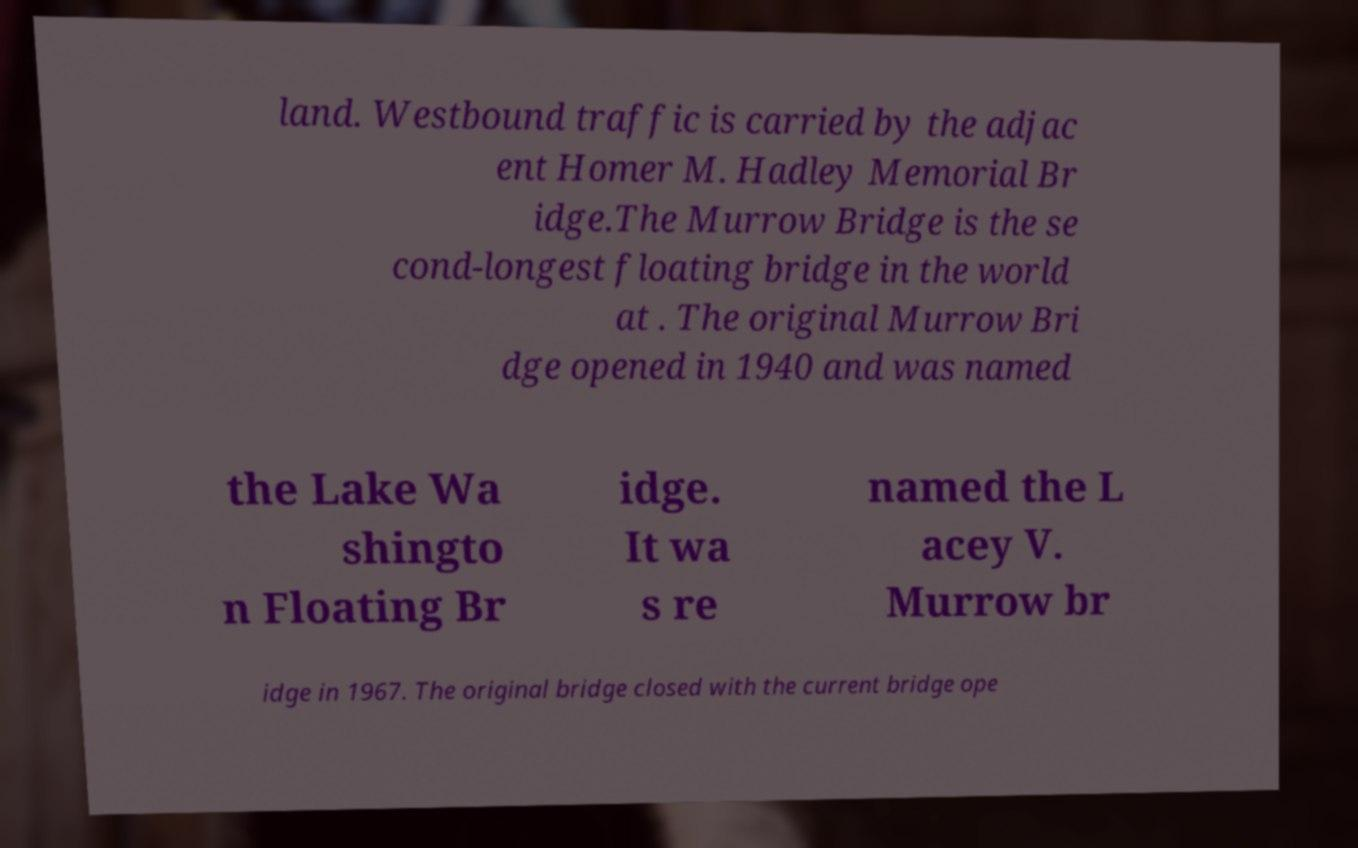Could you extract and type out the text from this image? land. Westbound traffic is carried by the adjac ent Homer M. Hadley Memorial Br idge.The Murrow Bridge is the se cond-longest floating bridge in the world at . The original Murrow Bri dge opened in 1940 and was named the Lake Wa shingto n Floating Br idge. It wa s re named the L acey V. Murrow br idge in 1967. The original bridge closed with the current bridge ope 